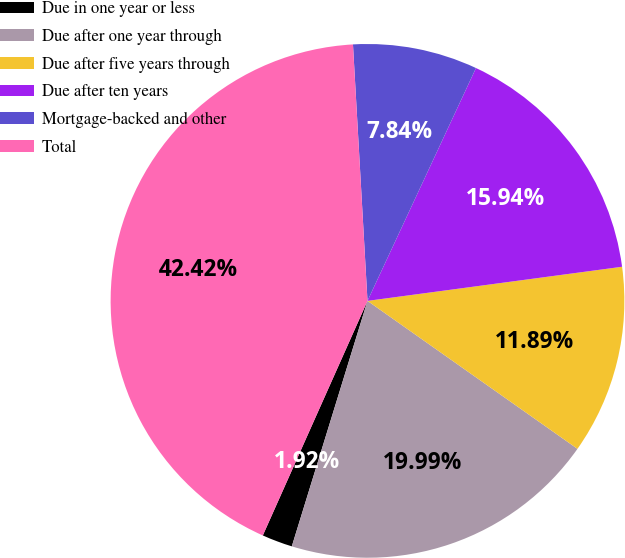<chart> <loc_0><loc_0><loc_500><loc_500><pie_chart><fcel>Due in one year or less<fcel>Due after one year through<fcel>Due after five years through<fcel>Due after ten years<fcel>Mortgage-backed and other<fcel>Total<nl><fcel>1.92%<fcel>19.99%<fcel>11.89%<fcel>15.94%<fcel>7.84%<fcel>42.42%<nl></chart> 